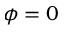Convert formula to latex. <formula><loc_0><loc_0><loc_500><loc_500>\phi = 0</formula> 